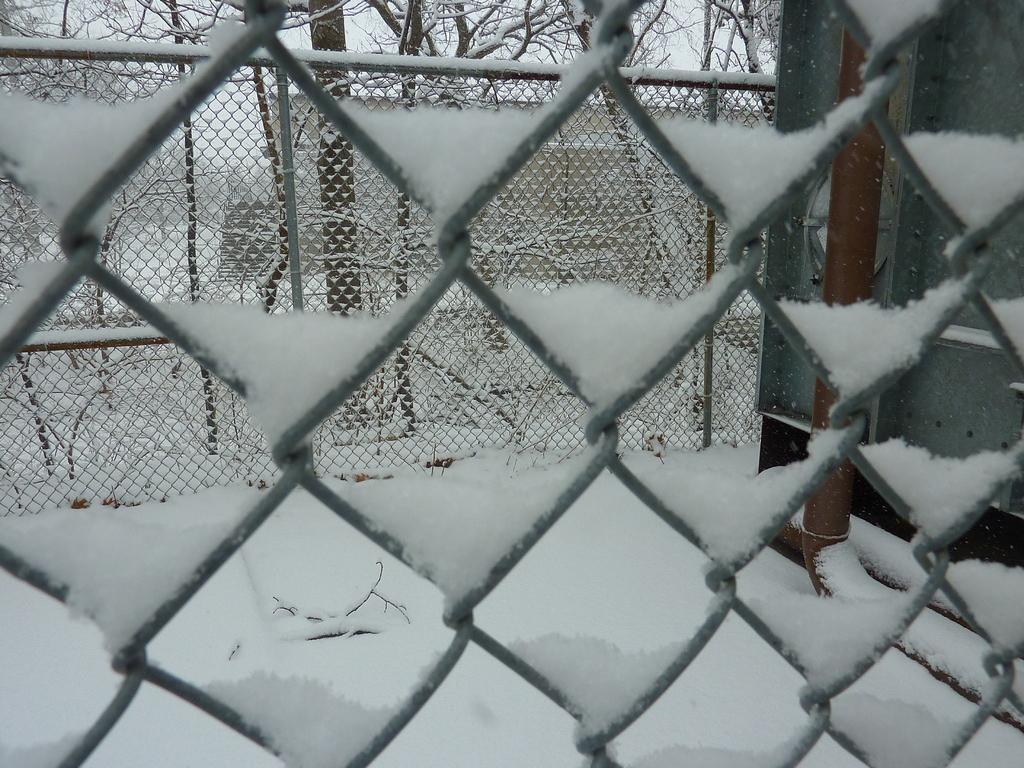Please provide a concise description of this image. This picture shows about a grill fencing net full of snow. Behind we can see another grill fencing net with Pipes and dry trees. 